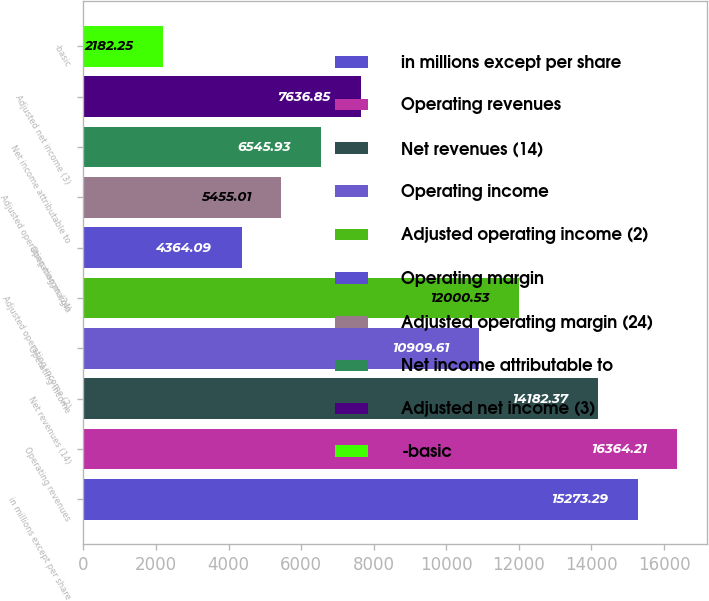Convert chart to OTSL. <chart><loc_0><loc_0><loc_500><loc_500><bar_chart><fcel>in millions except per share<fcel>Operating revenues<fcel>Net revenues (14)<fcel>Operating income<fcel>Adjusted operating income (2)<fcel>Operating margin<fcel>Adjusted operating margin (24)<fcel>Net income attributable to<fcel>Adjusted net income (3)<fcel>-basic<nl><fcel>15273.3<fcel>16364.2<fcel>14182.4<fcel>10909.6<fcel>12000.5<fcel>4364.09<fcel>5455.01<fcel>6545.93<fcel>7636.85<fcel>2182.25<nl></chart> 